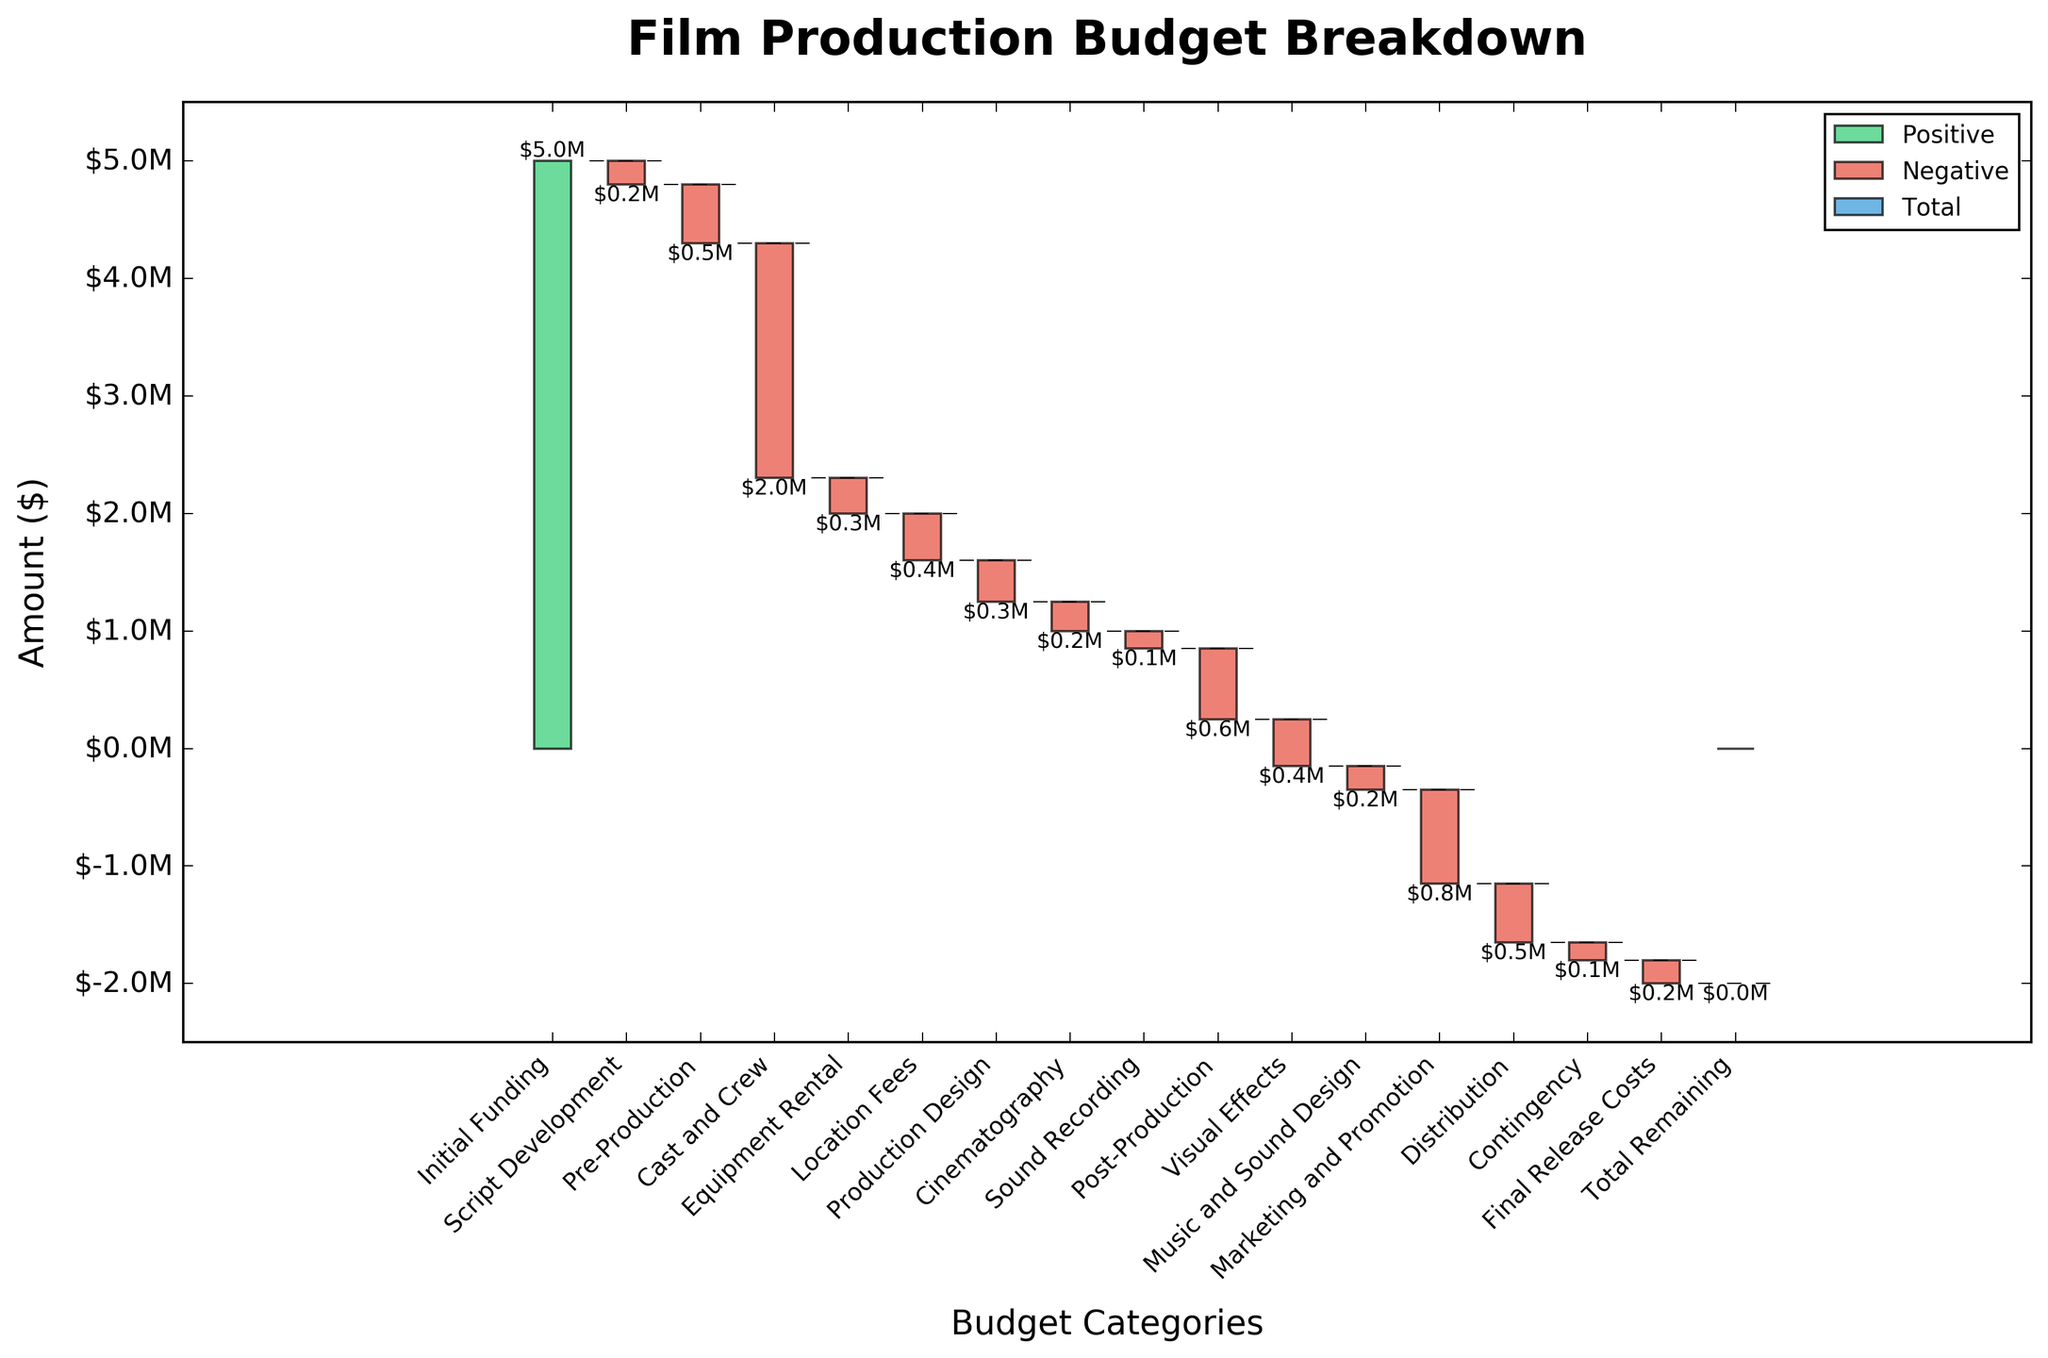What's the title of the chart? The title is typically placed at the top of the chart. In this case, it's clear from the chart that it reads "Film Production Budget Breakdown".
Answer: Film Production Budget Breakdown What does the y-axis represent? The y-axis label usually describes the values of the data points. Here, it is labeled as 'Amount ($)', indicating it shows the amount in dollars.
Answer: Amount ($) How much was spent on Cast and Crew? To find the Cast and Crew expenditure, look for the associated bar and its label in the chart. This bar is marked as -$2.0M, which shows the amount spent.
Answer: $2 million What were the initial funding and final release costs? The initial funding is shown as the first positive bar, represented as $5M. The final release cost is listed at the end of the chart as -$0.2M.
Answer: Initial Funding: $5 million; Final Release Costs: $200,000 Which category had the highest expenditure? The category with the largest negative (red) bar depicts the highest expenditure. The Cast and Crew category has the largest negative value at -$2M.
Answer: Cast and Crew What's the difference in expenditure between Equipment Rental and Location Fees? Equipment Rental is -$300,000, and Location Fees is -$400,000. The difference is $400,000 - $300,000 = $100,000.
Answer: $100,000 What is the total amount spent on Pre-Production, Production Design, and Cinematography combined? The amounts are Pre-Production: -$500,000, Production Design: -$350,000, and Cinematography: -$250,000. Sum them up: -$500,000 + -$350,000 + -$250,000 = -$1,100,000.
Answer: $1,100,000 How does the final bar relate to the total expenditures shown in the chart? The final bar labeled Total Remaining shows $0. This indicates that all expenditures sum up exactly to the initial funding, balanced without surplus or deficit.
Answer: Balances to zero Considering the marketing and promotion, was this expenditure more or less than post-production? Marketing and Promotion are at -$800,000, and Post-Production is -$600,000. Marketing and Promotion expenses are more by -$800,000 - (-$600,000) = -$200,000.
Answer: More by $200,000 Were visual effects costs higher or lower than Music and Sound Design? Visual Effects expense is -$400,000 and Music and Sound Design is -$200,000. Hence, Visual Effects cost more.
Answer: Higher 